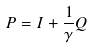<formula> <loc_0><loc_0><loc_500><loc_500>P = I + \frac { 1 } { \gamma } Q</formula> 